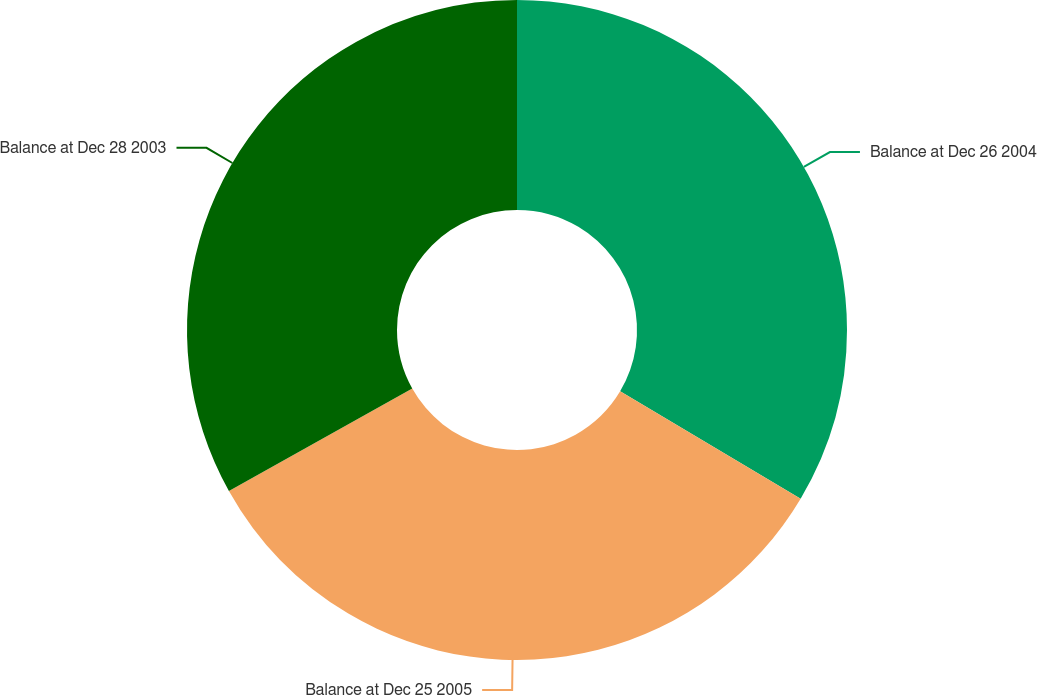<chart> <loc_0><loc_0><loc_500><loc_500><pie_chart><fcel>Balance at Dec 26 2004<fcel>Balance at Dec 25 2005<fcel>Balance at Dec 28 2003<nl><fcel>33.54%<fcel>33.35%<fcel>33.11%<nl></chart> 